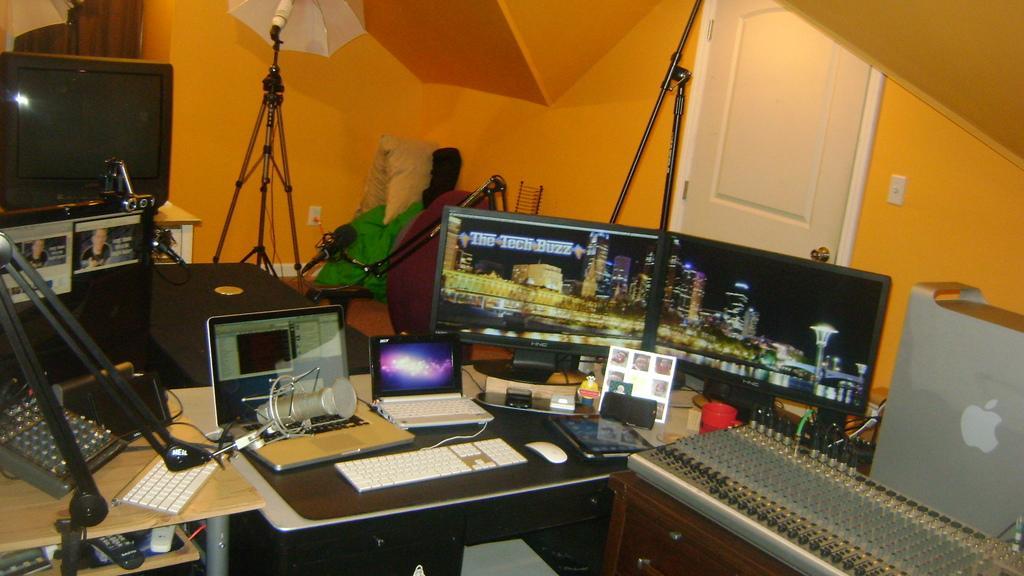In one or two sentences, can you explain what this image depicts? There are tables. On the tables there are keyboards, mouse, laptops, computers, remote, CPU and many other things. Also there is a television on the surface. There are mics with mic stands. Also there is an umbrella on a tripod stand. In the back there is a wall. Also there is a door 